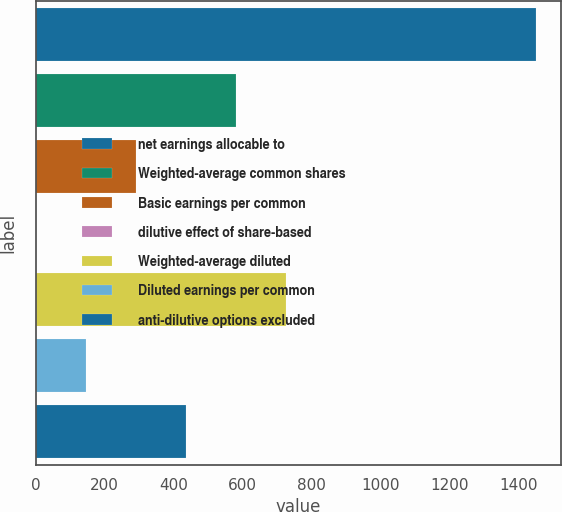Convert chart to OTSL. <chart><loc_0><loc_0><loc_500><loc_500><bar_chart><fcel>net earnings allocable to<fcel>Weighted-average common shares<fcel>Basic earnings per common<fcel>dilutive effect of share-based<fcel>Weighted-average diluted<fcel>Diluted earnings per common<fcel>anti-dilutive options excluded<nl><fcel>1449<fcel>580.8<fcel>291.4<fcel>2<fcel>725.5<fcel>146.7<fcel>436.1<nl></chart> 